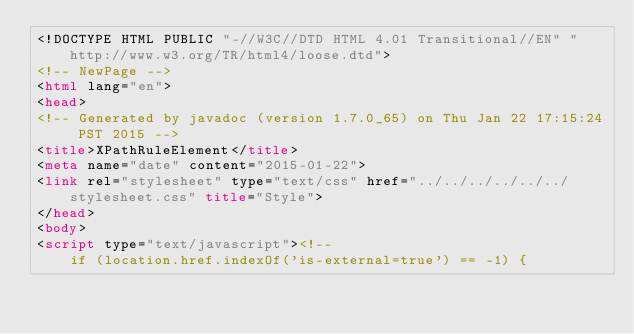<code> <loc_0><loc_0><loc_500><loc_500><_HTML_><!DOCTYPE HTML PUBLIC "-//W3C//DTD HTML 4.01 Transitional//EN" "http://www.w3.org/TR/html4/loose.dtd">
<!-- NewPage -->
<html lang="en">
<head>
<!-- Generated by javadoc (version 1.7.0_65) on Thu Jan 22 17:15:24 PST 2015 -->
<title>XPathRuleElement</title>
<meta name="date" content="2015-01-22">
<link rel="stylesheet" type="text/css" href="../../../../../../stylesheet.css" title="Style">
</head>
<body>
<script type="text/javascript"><!--
    if (location.href.indexOf('is-external=true') == -1) {</code> 